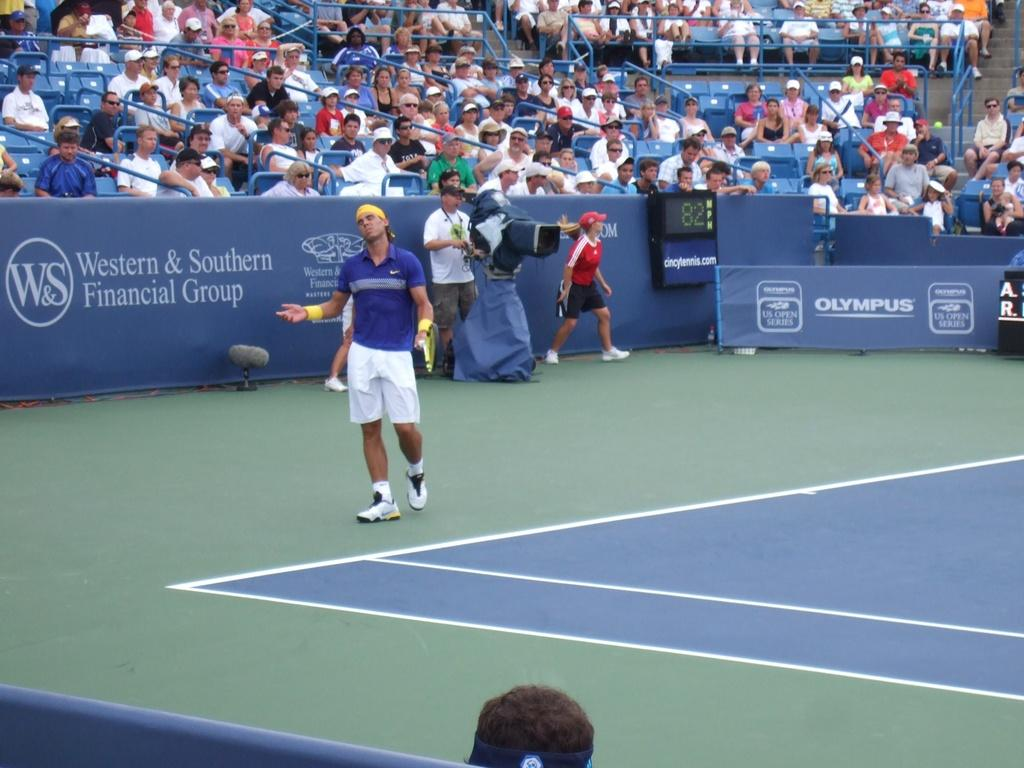What is the setting of the image? The setting of the image is a play area. What can be seen in the background of the image? There are hoarding boards visible in the image. What are the people in the image doing? The persons in the image are sitting on chairs behind the hoarding boards. What type of fruit is being thought about by the person sitting on the chair? There is no indication in the image that anyone is thinking about fruit, so it cannot be determined from the picture. 